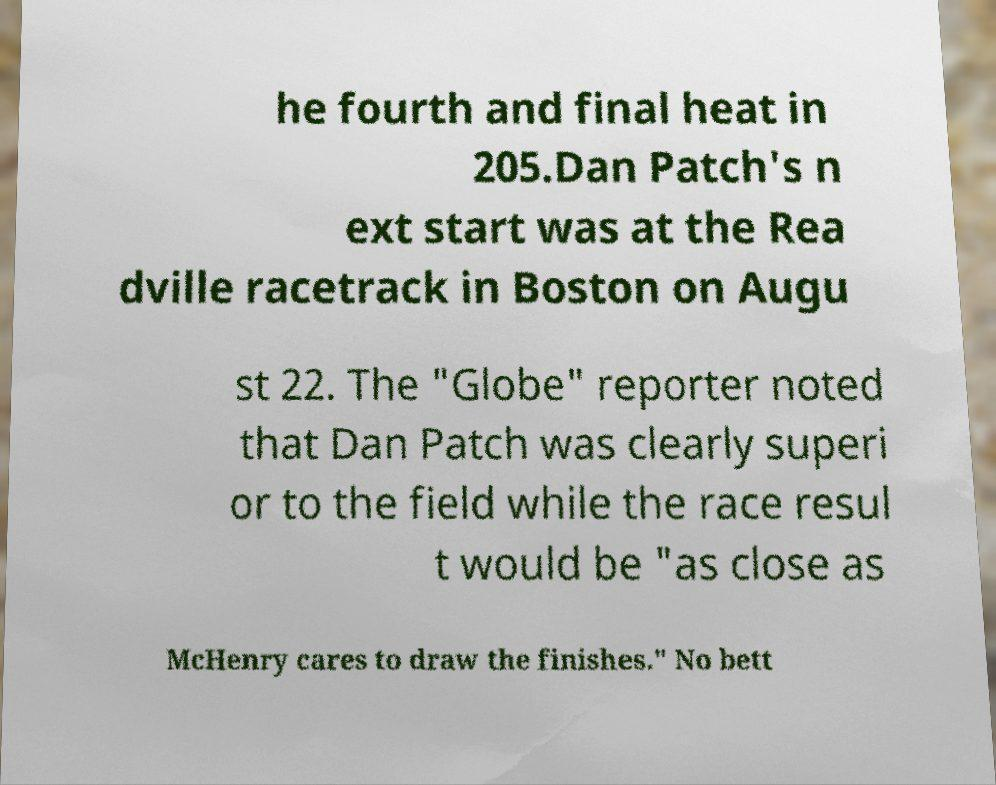Please identify and transcribe the text found in this image. he fourth and final heat in 205.Dan Patch's n ext start was at the Rea dville racetrack in Boston on Augu st 22. The "Globe" reporter noted that Dan Patch was clearly superi or to the field while the race resul t would be "as close as McHenry cares to draw the finishes." No bett 